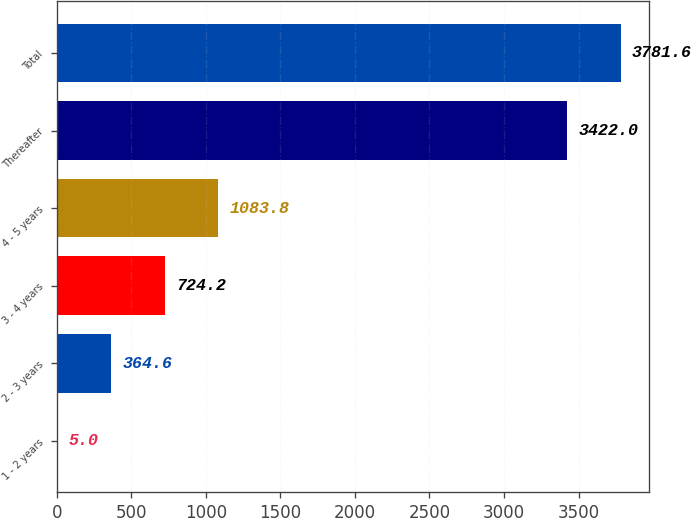<chart> <loc_0><loc_0><loc_500><loc_500><bar_chart><fcel>1 - 2 years<fcel>2 - 3 years<fcel>3 - 4 years<fcel>4 - 5 years<fcel>Thereafter<fcel>Total<nl><fcel>5<fcel>364.6<fcel>724.2<fcel>1083.8<fcel>3422<fcel>3781.6<nl></chart> 